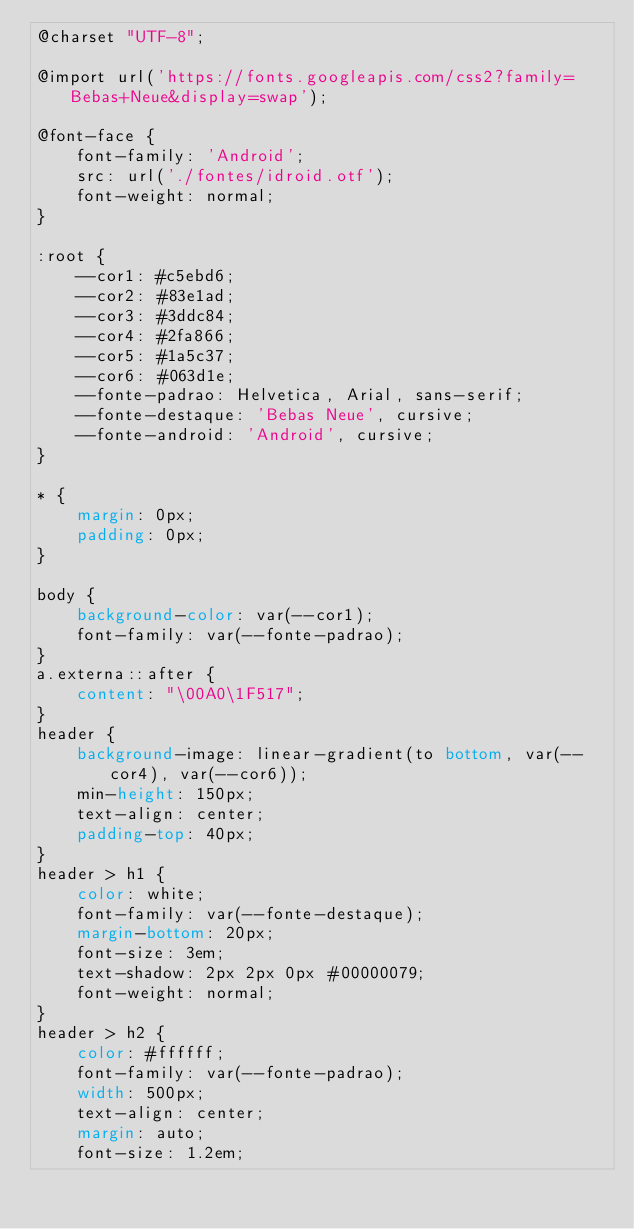<code> <loc_0><loc_0><loc_500><loc_500><_CSS_>@charset "UTF-8";

@import url('https://fonts.googleapis.com/css2?family=Bebas+Neue&display=swap');

@font-face {
    font-family: 'Android';
    src: url('./fontes/idroid.otf');
    font-weight: normal;
}

:root {
    --cor1: #c5ebd6;
    --cor2: #83e1ad;
    --cor3: #3ddc84;
    --cor4: #2fa866;
    --cor5: #1a5c37;
    --cor6: #063d1e;
    --fonte-padrao: Helvetica, Arial, sans-serif;
    --fonte-destaque: 'Bebas Neue', cursive;
    --fonte-android: 'Android', cursive;
}

* {
    margin: 0px;
    padding: 0px;
}

body {
    background-color: var(--cor1);
    font-family: var(--fonte-padrao);
}
a.externa::after {
    content: "\00A0\1F517";
}
header {
    background-image: linear-gradient(to bottom, var(--cor4), var(--cor6));
    min-height: 150px;
    text-align: center;
    padding-top: 40px;
}
header > h1 {
    color: white;
    font-family: var(--fonte-destaque);
    margin-bottom: 20px;
    font-size: 3em;
    text-shadow: 2px 2px 0px #00000079;
    font-weight: normal;
}
header > h2 {
    color: #ffffff;
    font-family: var(--fonte-padrao);
    width: 500px;
    text-align: center;
    margin: auto;
    font-size: 1.2em;</code> 